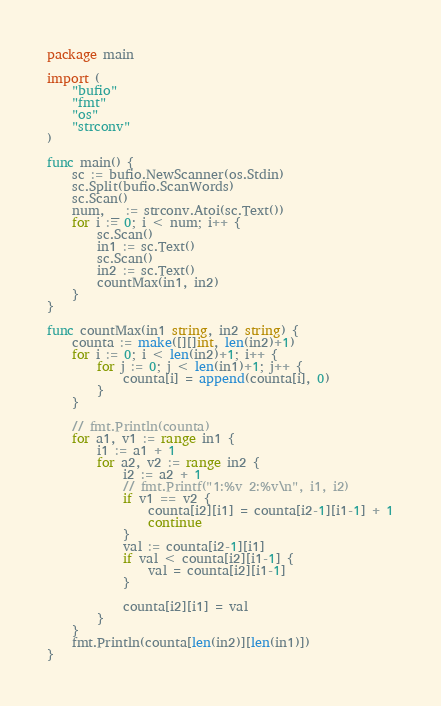Convert code to text. <code><loc_0><loc_0><loc_500><loc_500><_Go_>package main

import (
	"bufio"
	"fmt"
	"os"
	"strconv"
)

func main() {
	sc := bufio.NewScanner(os.Stdin)
	sc.Split(bufio.ScanWords)
	sc.Scan()
	num, _ := strconv.Atoi(sc.Text())
	for i := 0; i < num; i++ {
		sc.Scan()
		in1 := sc.Text()
		sc.Scan()
		in2 := sc.Text()
		countMax(in1, in2)
	}
}

func countMax(in1 string, in2 string) {
	counta := make([][]int, len(in2)+1)
	for i := 0; i < len(in2)+1; i++ {
		for j := 0; j < len(in1)+1; j++ {
			counta[i] = append(counta[i], 0)
		}
	}

	// fmt.Println(counta)
	for a1, v1 := range in1 {
		i1 := a1 + 1
		for a2, v2 := range in2 {
			i2 := a2 + 1
			// fmt.Printf("1:%v 2:%v\n", i1, i2)
			if v1 == v2 {
				counta[i2][i1] = counta[i2-1][i1-1] + 1
				continue
			}
			val := counta[i2-1][i1]
			if val < counta[i2][i1-1] {
				val = counta[i2][i1-1]
			}

			counta[i2][i1] = val
		}
	}
	fmt.Println(counta[len(in2)][len(in1)])
}

</code> 